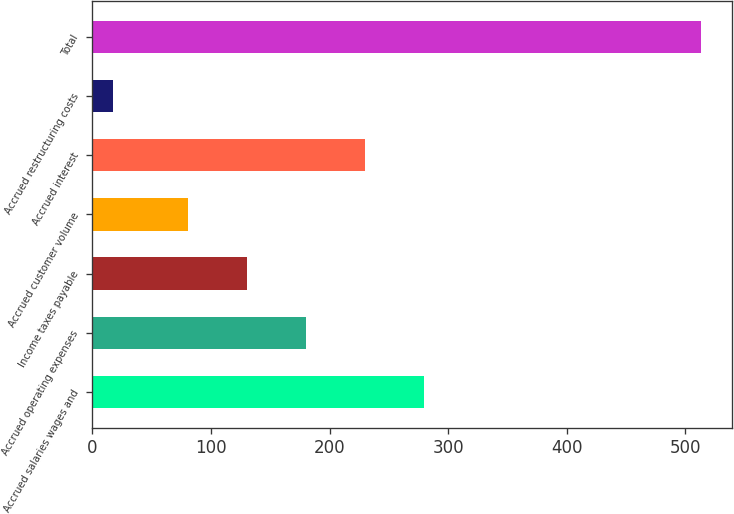Convert chart. <chart><loc_0><loc_0><loc_500><loc_500><bar_chart><fcel>Accrued salaries wages and<fcel>Accrued operating expenses<fcel>Income taxes payable<fcel>Accrued customer volume<fcel>Accrued interest<fcel>Accrued restructuring costs<fcel>Total<nl><fcel>279.3<fcel>180.1<fcel>130.5<fcel>80.9<fcel>229.7<fcel>17.5<fcel>513.5<nl></chart> 